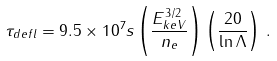Convert formula to latex. <formula><loc_0><loc_0><loc_500><loc_500>\tau _ { d e f l } = 9 . 5 \times 1 0 ^ { 7 } s \left ( \frac { E _ { k e V } ^ { 3 / 2 } } { n _ { e } } \right ) \left ( \frac { 2 0 } { \ln \Lambda } \right ) \, .</formula> 